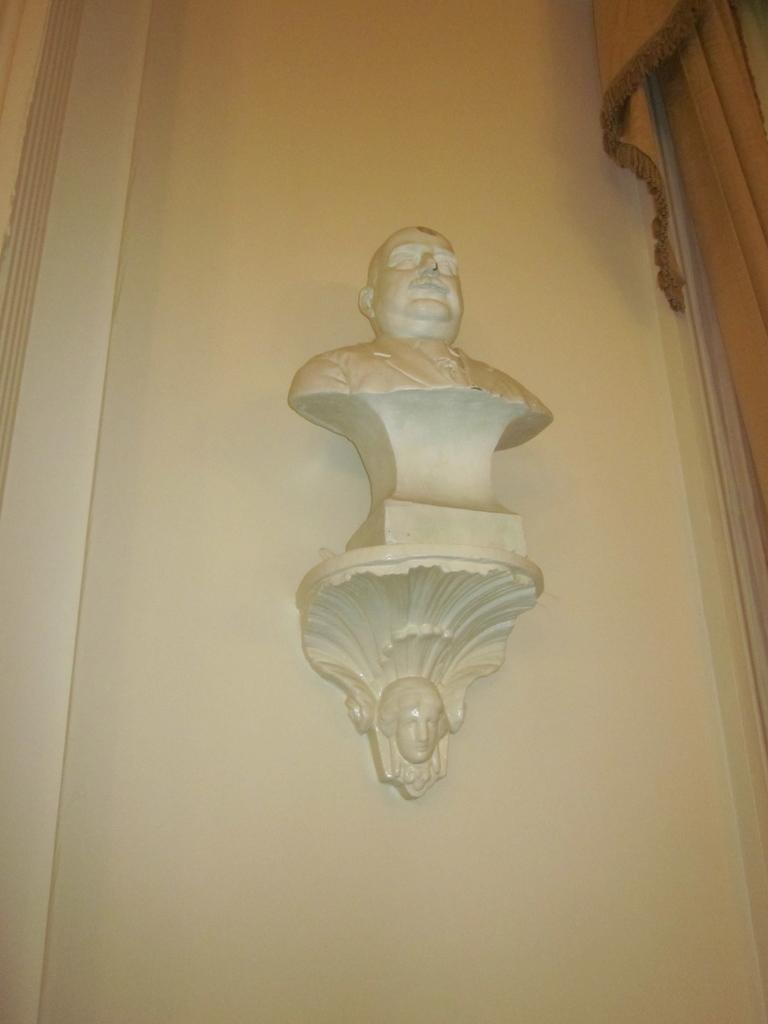What is on the white wall in the image? There are sculptures on a white wall in the image. What else can be seen on the right side of the image? There is a curtain on the right side of the image. How many houses can be seen in the image? There are no houses visible in the image. Can you describe the goose that is sitting on the curtain? There is no goose present in the image; only sculptures on a white wall and a curtain are visible. 